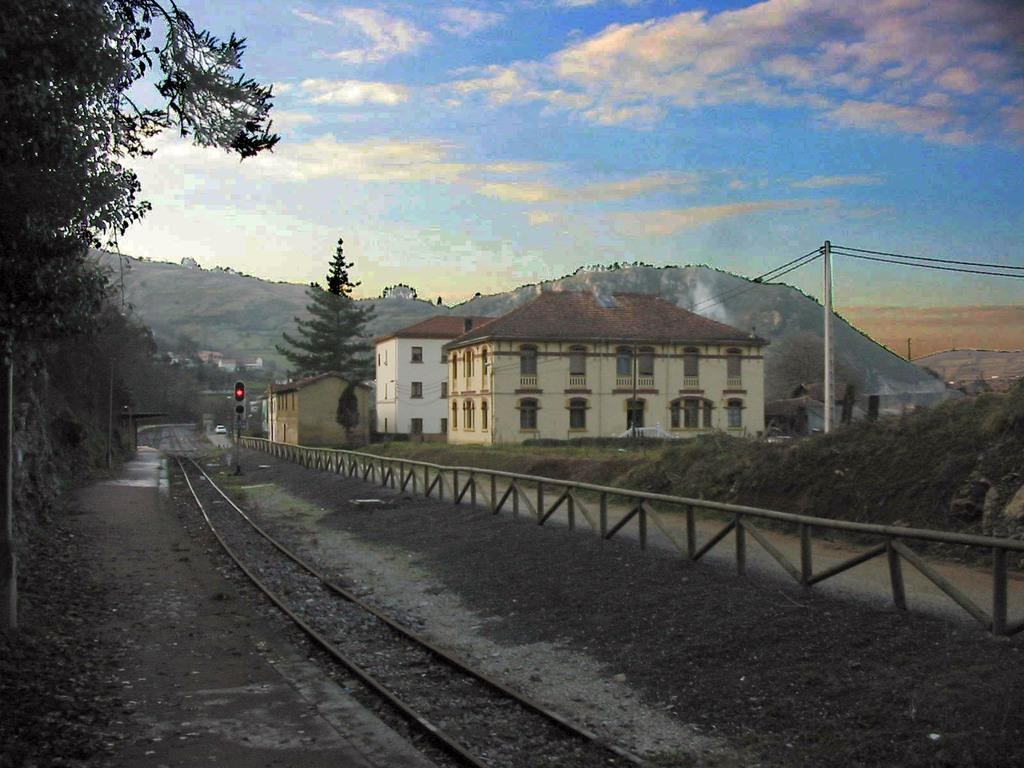What type of natural elements can be seen in the image? There are trees in the image. What type of man-made structures can be seen in the image? There are tracks, a fence, signal lights, and buildings in the image. What can be seen in the background of the image? There are hills, a pole, and clouds in the background of the image. Can you see any animals from the zoo in the image? There is no zoo present in the image, so no animals from a zoo can be seen. Is there a person using a rake in the image? There is no person or rake present in the image. 